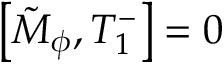<formula> <loc_0><loc_0><loc_500><loc_500>\left [ \tilde { M } _ { \phi } , T _ { 1 } ^ { - } \right ] = 0</formula> 